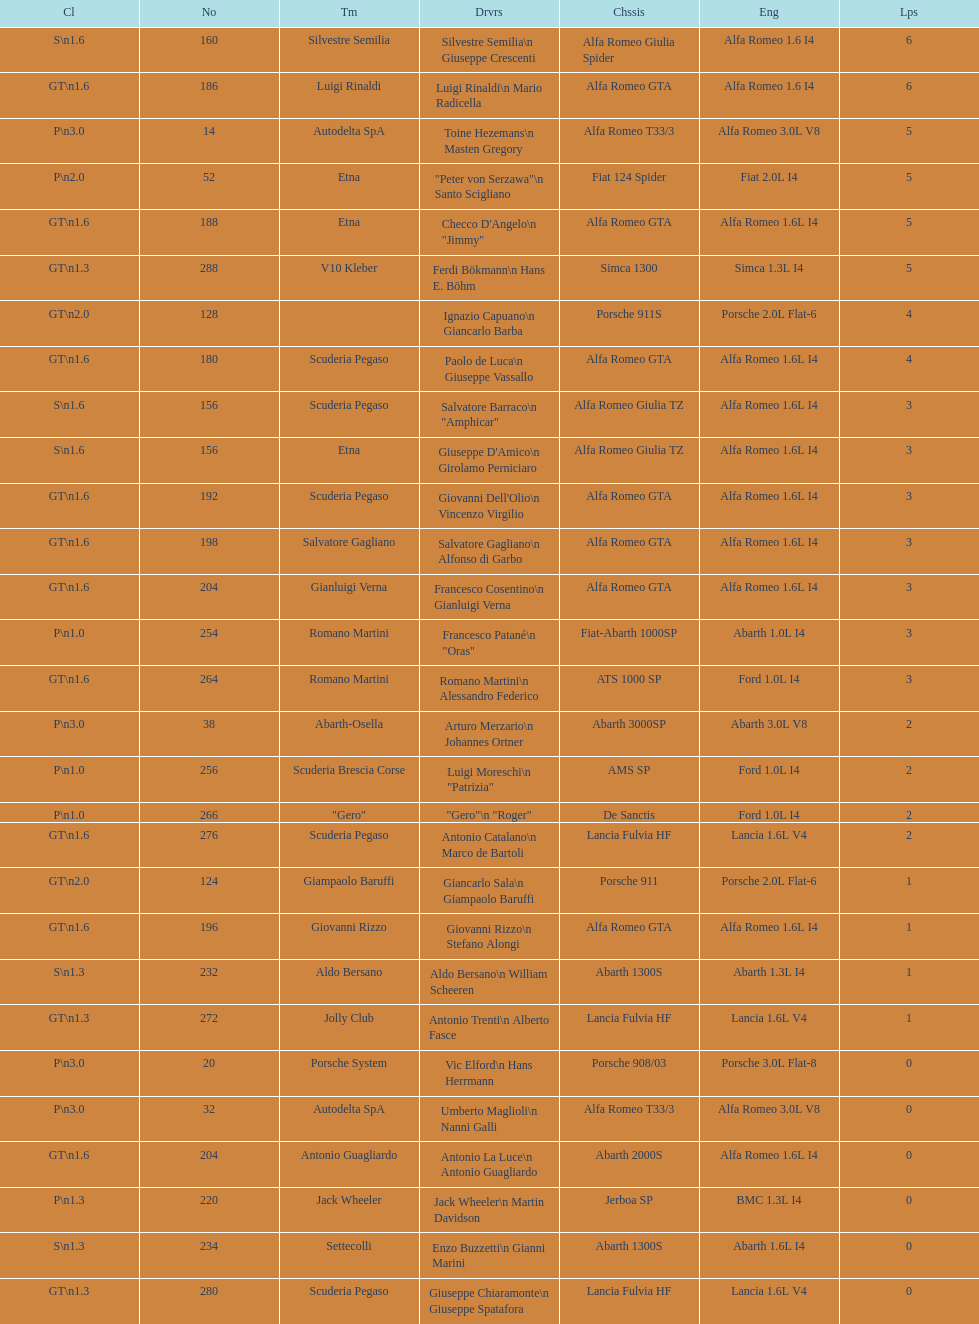What class is below s 1.6? GT 1.6. 